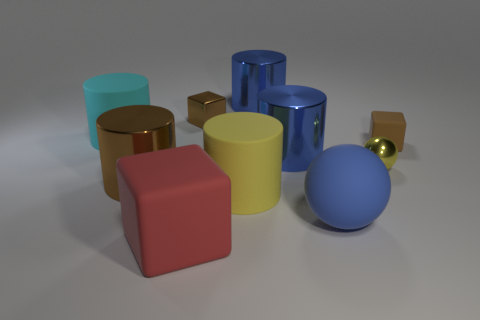Is the red object the same size as the cyan thing?
Give a very brief answer. Yes. There is a blue cylinder behind the rubber cylinder that is left of the yellow cylinder; how big is it?
Your answer should be compact. Large. There is a matte thing that is both left of the large yellow matte cylinder and behind the blue sphere; how big is it?
Keep it short and to the point. Large. How many blue objects have the same size as the cyan object?
Your answer should be very brief. 3. How many rubber things are either big gray things or large cylinders?
Keep it short and to the point. 2. What size is the cylinder that is the same color as the tiny rubber block?
Make the answer very short. Large. What material is the ball in front of the large matte cylinder that is in front of the cyan matte cylinder?
Offer a terse response. Rubber. What number of objects are small purple matte cylinders or big matte objects in front of the small yellow sphere?
Your answer should be compact. 3. What is the size of the brown cylinder that is made of the same material as the small yellow ball?
Ensure brevity in your answer.  Large. How many green things are either big metal objects or large rubber objects?
Keep it short and to the point. 0. 